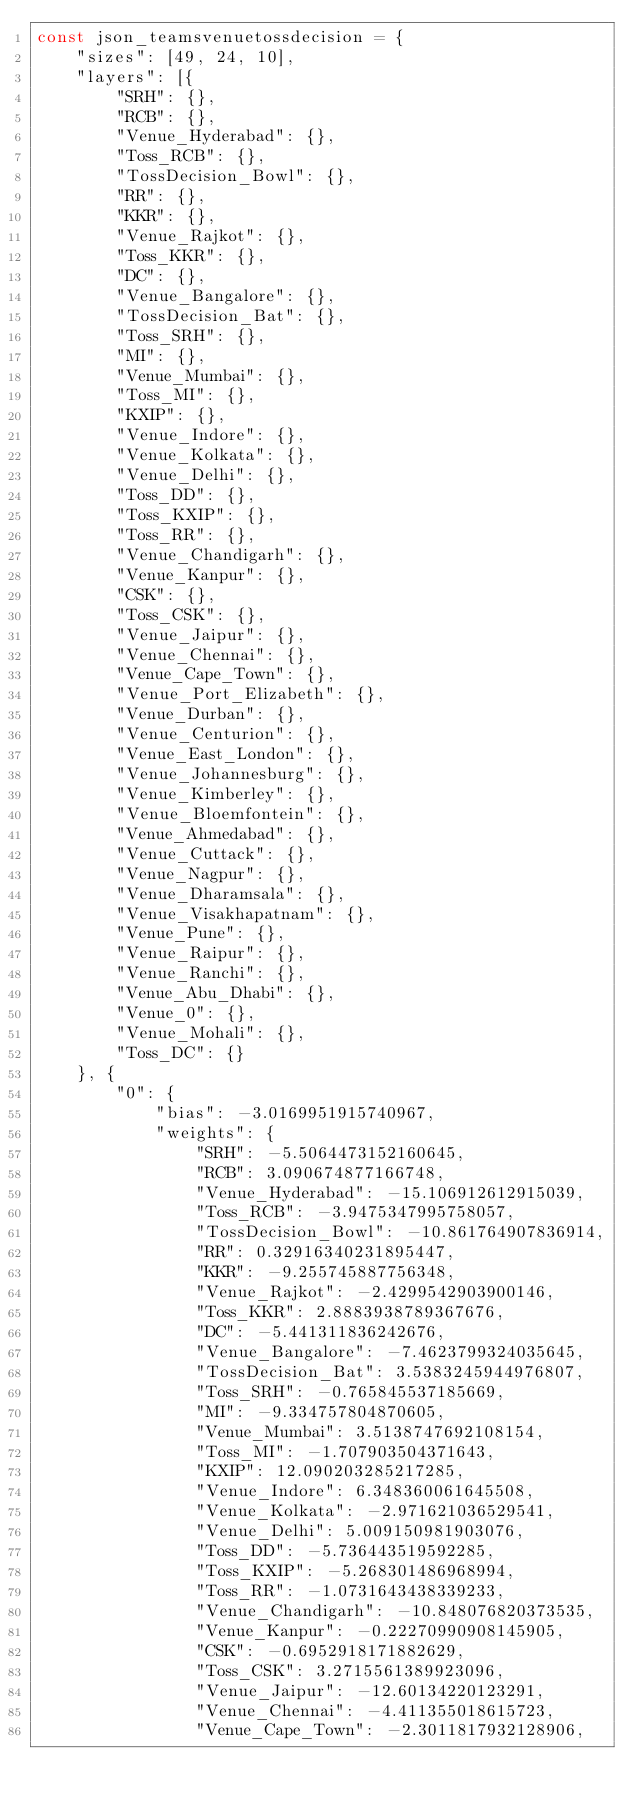<code> <loc_0><loc_0><loc_500><loc_500><_JavaScript_>const json_teamsvenuetossdecision = {
    "sizes": [49, 24, 10],
    "layers": [{
        "SRH": {},
        "RCB": {},
        "Venue_Hyderabad": {},
        "Toss_RCB": {},
        "TossDecision_Bowl": {},
        "RR": {},
        "KKR": {},
        "Venue_Rajkot": {},
        "Toss_KKR": {},
        "DC": {},
        "Venue_Bangalore": {},
        "TossDecision_Bat": {},
        "Toss_SRH": {},
        "MI": {},
        "Venue_Mumbai": {},
        "Toss_MI": {},
        "KXIP": {},
        "Venue_Indore": {},
        "Venue_Kolkata": {},
        "Venue_Delhi": {},
        "Toss_DD": {},
        "Toss_KXIP": {},
        "Toss_RR": {},
        "Venue_Chandigarh": {},
        "Venue_Kanpur": {},
        "CSK": {},
        "Toss_CSK": {},
        "Venue_Jaipur": {},
        "Venue_Chennai": {},
        "Venue_Cape_Town": {},
        "Venue_Port_Elizabeth": {},
        "Venue_Durban": {},
        "Venue_Centurion": {},
        "Venue_East_London": {},
        "Venue_Johannesburg": {},
        "Venue_Kimberley": {},
        "Venue_Bloemfontein": {},
        "Venue_Ahmedabad": {},
        "Venue_Cuttack": {},
        "Venue_Nagpur": {},
        "Venue_Dharamsala": {},
        "Venue_Visakhapatnam": {},
        "Venue_Pune": {},
        "Venue_Raipur": {},
        "Venue_Ranchi": {},
        "Venue_Abu_Dhabi": {},
        "Venue_0": {},
        "Venue_Mohali": {},
        "Toss_DC": {}
    }, {
        "0": {
            "bias": -3.0169951915740967,
            "weights": {
                "SRH": -5.5064473152160645,
                "RCB": 3.090674877166748,
                "Venue_Hyderabad": -15.106912612915039,
                "Toss_RCB": -3.9475347995758057,
                "TossDecision_Bowl": -10.861764907836914,
                "RR": 0.32916340231895447,
                "KKR": -9.255745887756348,
                "Venue_Rajkot": -2.4299542903900146,
                "Toss_KKR": 2.8883938789367676,
                "DC": -5.441311836242676,
                "Venue_Bangalore": -7.4623799324035645,
                "TossDecision_Bat": 3.5383245944976807,
                "Toss_SRH": -0.765845537185669,
                "MI": -9.334757804870605,
                "Venue_Mumbai": 3.5138747692108154,
                "Toss_MI": -1.707903504371643,
                "KXIP": 12.090203285217285,
                "Venue_Indore": 6.348360061645508,
                "Venue_Kolkata": -2.971621036529541,
                "Venue_Delhi": 5.009150981903076,
                "Toss_DD": -5.736443519592285,
                "Toss_KXIP": -5.268301486968994,
                "Toss_RR": -1.0731643438339233,
                "Venue_Chandigarh": -10.848076820373535,
                "Venue_Kanpur": -0.22270990908145905,
                "CSK": -0.6952918171882629,
                "Toss_CSK": 3.2715561389923096,
                "Venue_Jaipur": -12.60134220123291,
                "Venue_Chennai": -4.411355018615723,
                "Venue_Cape_Town": -2.3011817932128906,</code> 